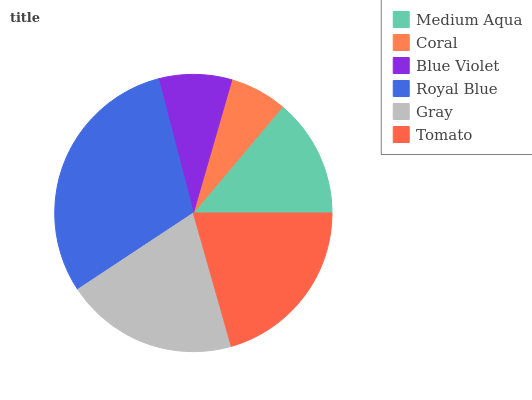Is Coral the minimum?
Answer yes or no. Yes. Is Royal Blue the maximum?
Answer yes or no. Yes. Is Blue Violet the minimum?
Answer yes or no. No. Is Blue Violet the maximum?
Answer yes or no. No. Is Blue Violet greater than Coral?
Answer yes or no. Yes. Is Coral less than Blue Violet?
Answer yes or no. Yes. Is Coral greater than Blue Violet?
Answer yes or no. No. Is Blue Violet less than Coral?
Answer yes or no. No. Is Gray the high median?
Answer yes or no. Yes. Is Medium Aqua the low median?
Answer yes or no. Yes. Is Royal Blue the high median?
Answer yes or no. No. Is Coral the low median?
Answer yes or no. No. 